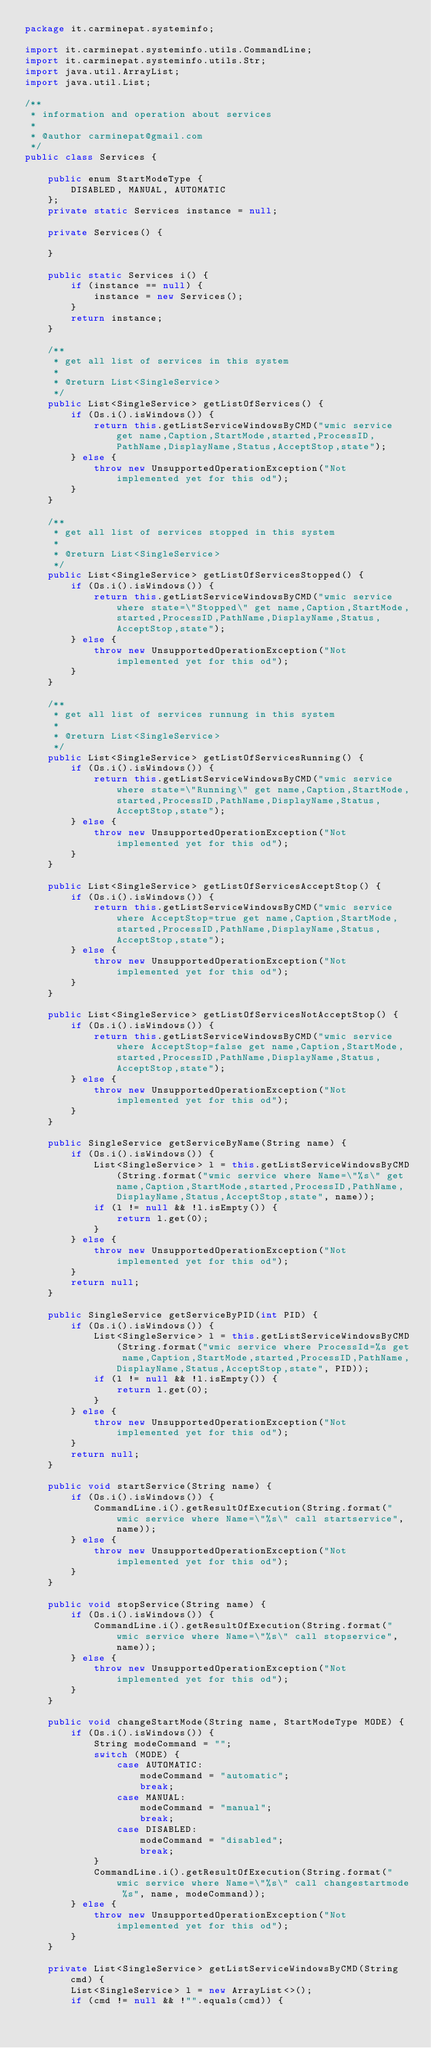Convert code to text. <code><loc_0><loc_0><loc_500><loc_500><_Java_>package it.carminepat.systeminfo;

import it.carminepat.systeminfo.utils.CommandLine;
import it.carminepat.systeminfo.utils.Str;
import java.util.ArrayList;
import java.util.List;

/**
 * information and operation about services
 *
 * @author carminepat@gmail.com
 */
public class Services {

    public enum StartModeType {
        DISABLED, MANUAL, AUTOMATIC
    };
    private static Services instance = null;

    private Services() {

    }

    public static Services i() {
        if (instance == null) {
            instance = new Services();
        }
        return instance;
    }

    /**
     * get all list of services in this system
     *
     * @return List<SingleService>
     */
    public List<SingleService> getListOfServices() {
        if (Os.i().isWindows()) {
            return this.getListServiceWindowsByCMD("wmic service get name,Caption,StartMode,started,ProcessID,PathName,DisplayName,Status,AcceptStop,state");
        } else {
            throw new UnsupportedOperationException("Not implemented yet for this od");
        }
    }

    /**
     * get all list of services stopped in this system
     *
     * @return List<SingleService>
     */
    public List<SingleService> getListOfServicesStopped() {
        if (Os.i().isWindows()) {
            return this.getListServiceWindowsByCMD("wmic service where state=\"Stopped\" get name,Caption,StartMode,started,ProcessID,PathName,DisplayName,Status,AcceptStop,state");
        } else {
            throw new UnsupportedOperationException("Not implemented yet for this od");
        }
    }

    /**
     * get all list of services runnung in this system
     *
     * @return List<SingleService>
     */
    public List<SingleService> getListOfServicesRunning() {
        if (Os.i().isWindows()) {
            return this.getListServiceWindowsByCMD("wmic service where state=\"Running\" get name,Caption,StartMode,started,ProcessID,PathName,DisplayName,Status,AcceptStop,state");
        } else {
            throw new UnsupportedOperationException("Not implemented yet for this od");
        }
    }

    public List<SingleService> getListOfServicesAcceptStop() {
        if (Os.i().isWindows()) {
            return this.getListServiceWindowsByCMD("wmic service where AcceptStop=true get name,Caption,StartMode,started,ProcessID,PathName,DisplayName,Status,AcceptStop,state");
        } else {
            throw new UnsupportedOperationException("Not implemented yet for this od");
        }
    }

    public List<SingleService> getListOfServicesNotAcceptStop() {
        if (Os.i().isWindows()) {
            return this.getListServiceWindowsByCMD("wmic service where AcceptStop=false get name,Caption,StartMode,started,ProcessID,PathName,DisplayName,Status,AcceptStop,state");
        } else {
            throw new UnsupportedOperationException("Not implemented yet for this od");
        }
    }

    public SingleService getServiceByName(String name) {
        if (Os.i().isWindows()) {
            List<SingleService> l = this.getListServiceWindowsByCMD(String.format("wmic service where Name=\"%s\" get name,Caption,StartMode,started,ProcessID,PathName,DisplayName,Status,AcceptStop,state", name));
            if (l != null && !l.isEmpty()) {
                return l.get(0);
            }
        } else {
            throw new UnsupportedOperationException("Not implemented yet for this od");
        }
        return null;
    }

    public SingleService getServiceByPID(int PID) {
        if (Os.i().isWindows()) {
            List<SingleService> l = this.getListServiceWindowsByCMD(String.format("wmic service where ProcessId=%s get name,Caption,StartMode,started,ProcessID,PathName,DisplayName,Status,AcceptStop,state", PID));
            if (l != null && !l.isEmpty()) {
                return l.get(0);
            }
        } else {
            throw new UnsupportedOperationException("Not implemented yet for this od");
        }
        return null;
    }

    public void startService(String name) {
        if (Os.i().isWindows()) {
            CommandLine.i().getResultOfExecution(String.format("wmic service where Name=\"%s\" call startservice", name));
        } else {
            throw new UnsupportedOperationException("Not implemented yet for this od");
        }
    }

    public void stopService(String name) {
        if (Os.i().isWindows()) {
            CommandLine.i().getResultOfExecution(String.format("wmic service where Name=\"%s\" call stopservice", name));
        } else {
            throw new UnsupportedOperationException("Not implemented yet for this od");
        }
    }

    public void changeStartMode(String name, StartModeType MODE) {
        if (Os.i().isWindows()) {
            String modeCommand = "";
            switch (MODE) {
                case AUTOMATIC:
                    modeCommand = "automatic";
                    break;
                case MANUAL:
                    modeCommand = "manual";
                    break;
                case DISABLED:
                    modeCommand = "disabled";
                    break;
            }
            CommandLine.i().getResultOfExecution(String.format("wmic service where Name=\"%s\" call changestartmode %s", name, modeCommand));
        } else {
            throw new UnsupportedOperationException("Not implemented yet for this od");
        }
    }

    private List<SingleService> getListServiceWindowsByCMD(String cmd) {
        List<SingleService> l = new ArrayList<>();
        if (cmd != null && !"".equals(cmd)) {</code> 